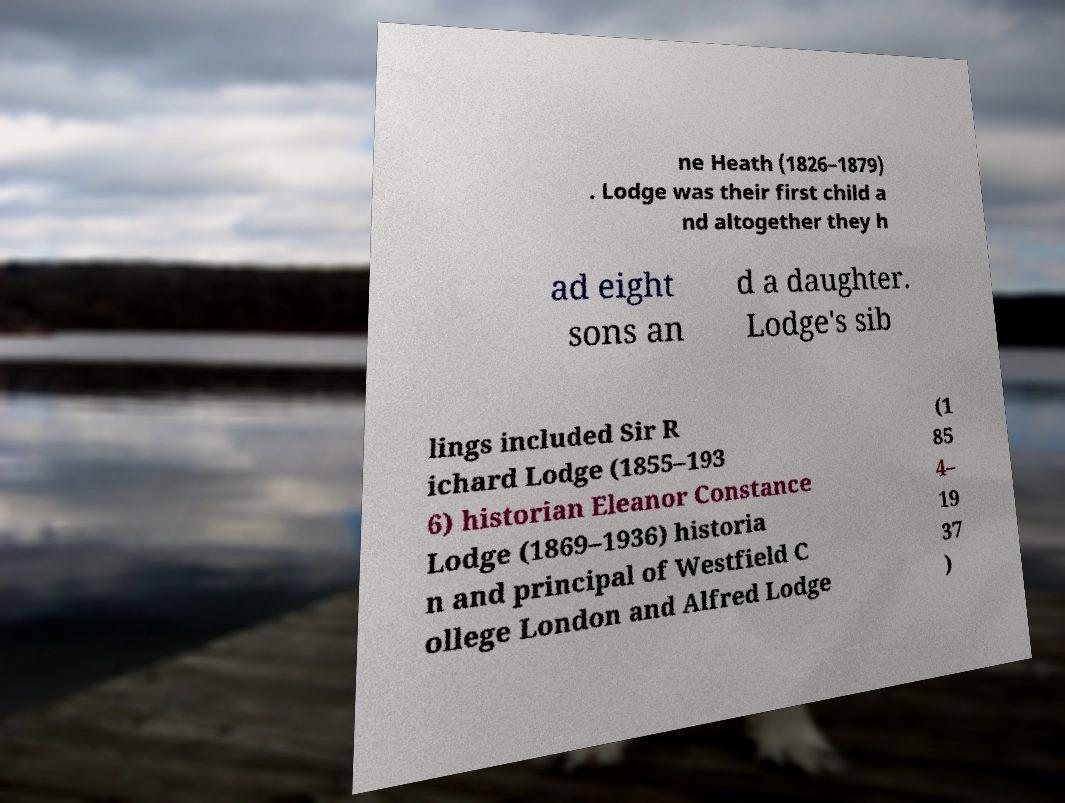Could you assist in decoding the text presented in this image and type it out clearly? ne Heath (1826–1879) . Lodge was their first child a nd altogether they h ad eight sons an d a daughter. Lodge's sib lings included Sir R ichard Lodge (1855–193 6) historian Eleanor Constance Lodge (1869–1936) historia n and principal of Westfield C ollege London and Alfred Lodge (1 85 4– 19 37 ) 